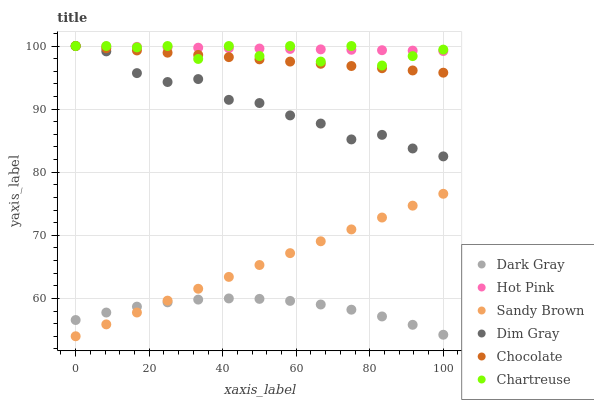Does Dark Gray have the minimum area under the curve?
Answer yes or no. Yes. Does Hot Pink have the maximum area under the curve?
Answer yes or no. Yes. Does Chocolate have the minimum area under the curve?
Answer yes or no. No. Does Chocolate have the maximum area under the curve?
Answer yes or no. No. Is Hot Pink the smoothest?
Answer yes or no. Yes. Is Chartreuse the roughest?
Answer yes or no. Yes. Is Chocolate the smoothest?
Answer yes or no. No. Is Chocolate the roughest?
Answer yes or no. No. Does Sandy Brown have the lowest value?
Answer yes or no. Yes. Does Chocolate have the lowest value?
Answer yes or no. No. Does Chartreuse have the highest value?
Answer yes or no. Yes. Does Dark Gray have the highest value?
Answer yes or no. No. Is Dark Gray less than Hot Pink?
Answer yes or no. Yes. Is Chartreuse greater than Dark Gray?
Answer yes or no. Yes. Does Sandy Brown intersect Dark Gray?
Answer yes or no. Yes. Is Sandy Brown less than Dark Gray?
Answer yes or no. No. Is Sandy Brown greater than Dark Gray?
Answer yes or no. No. Does Dark Gray intersect Hot Pink?
Answer yes or no. No. 